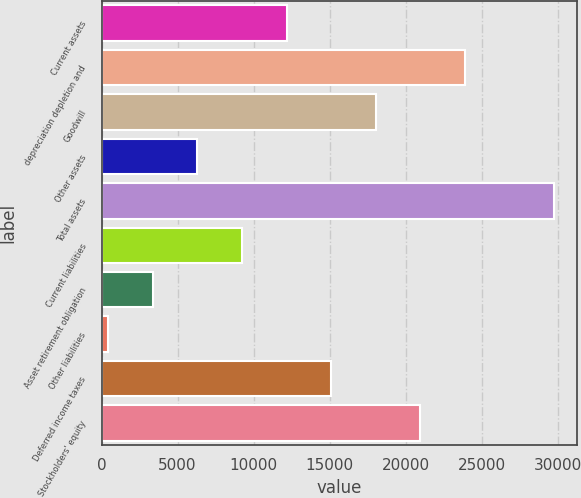<chart> <loc_0><loc_0><loc_500><loc_500><bar_chart><fcel>Current assets<fcel>depreciation depletion and<fcel>Goodwill<fcel>Other assets<fcel>Total assets<fcel>Current liabilities<fcel>Asset retirement obligation<fcel>Other liabilities<fcel>Deferred income taxes<fcel>Stockholders' equity<nl><fcel>12157.2<fcel>23876.4<fcel>18016.8<fcel>6297.6<fcel>29736<fcel>9227.4<fcel>3367.8<fcel>438<fcel>15087<fcel>20946.6<nl></chart> 